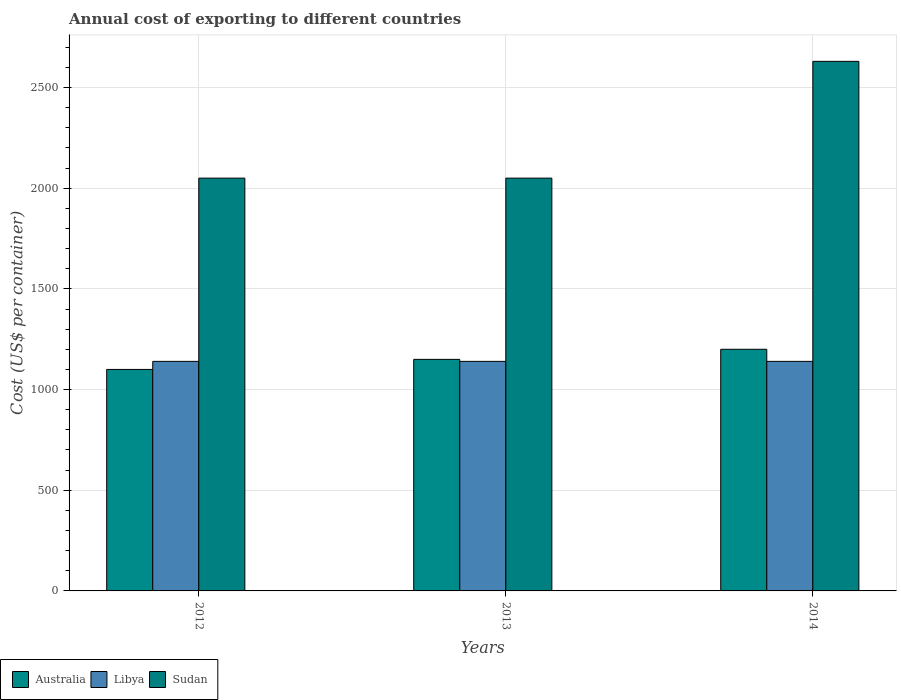How many different coloured bars are there?
Offer a terse response. 3. How many groups of bars are there?
Your response must be concise. 3. How many bars are there on the 1st tick from the left?
Offer a terse response. 3. What is the label of the 3rd group of bars from the left?
Offer a terse response. 2014. What is the total annual cost of exporting in Sudan in 2012?
Give a very brief answer. 2050. Across all years, what is the maximum total annual cost of exporting in Australia?
Provide a succinct answer. 1200. Across all years, what is the minimum total annual cost of exporting in Libya?
Your answer should be very brief. 1140. In which year was the total annual cost of exporting in Libya maximum?
Provide a short and direct response. 2012. What is the total total annual cost of exporting in Libya in the graph?
Offer a terse response. 3420. What is the difference between the total annual cost of exporting in Sudan in 2012 and that in 2014?
Provide a short and direct response. -580. What is the difference between the total annual cost of exporting in Australia in 2014 and the total annual cost of exporting in Sudan in 2012?
Make the answer very short. -850. What is the average total annual cost of exporting in Australia per year?
Keep it short and to the point. 1150. In the year 2013, what is the difference between the total annual cost of exporting in Sudan and total annual cost of exporting in Libya?
Offer a terse response. 910. What is the ratio of the total annual cost of exporting in Sudan in 2013 to that in 2014?
Ensure brevity in your answer.  0.78. Is the difference between the total annual cost of exporting in Sudan in 2012 and 2014 greater than the difference between the total annual cost of exporting in Libya in 2012 and 2014?
Your answer should be compact. No. What is the difference between the highest and the lowest total annual cost of exporting in Australia?
Ensure brevity in your answer.  100. Is the sum of the total annual cost of exporting in Australia in 2012 and 2013 greater than the maximum total annual cost of exporting in Libya across all years?
Your answer should be very brief. Yes. What does the 3rd bar from the left in 2012 represents?
Your answer should be very brief. Sudan. What does the 2nd bar from the right in 2013 represents?
Your answer should be compact. Libya. Is it the case that in every year, the sum of the total annual cost of exporting in Australia and total annual cost of exporting in Sudan is greater than the total annual cost of exporting in Libya?
Offer a very short reply. Yes. How many bars are there?
Make the answer very short. 9. What is the difference between two consecutive major ticks on the Y-axis?
Provide a short and direct response. 500. Are the values on the major ticks of Y-axis written in scientific E-notation?
Offer a terse response. No. Does the graph contain any zero values?
Your response must be concise. No. Does the graph contain grids?
Ensure brevity in your answer.  Yes. How are the legend labels stacked?
Ensure brevity in your answer.  Horizontal. What is the title of the graph?
Offer a very short reply. Annual cost of exporting to different countries. What is the label or title of the X-axis?
Your answer should be very brief. Years. What is the label or title of the Y-axis?
Offer a terse response. Cost (US$ per container). What is the Cost (US$ per container) in Australia in 2012?
Keep it short and to the point. 1100. What is the Cost (US$ per container) of Libya in 2012?
Give a very brief answer. 1140. What is the Cost (US$ per container) in Sudan in 2012?
Offer a terse response. 2050. What is the Cost (US$ per container) in Australia in 2013?
Make the answer very short. 1150. What is the Cost (US$ per container) of Libya in 2013?
Keep it short and to the point. 1140. What is the Cost (US$ per container) of Sudan in 2013?
Give a very brief answer. 2050. What is the Cost (US$ per container) of Australia in 2014?
Offer a terse response. 1200. What is the Cost (US$ per container) in Libya in 2014?
Offer a very short reply. 1140. What is the Cost (US$ per container) of Sudan in 2014?
Offer a terse response. 2630. Across all years, what is the maximum Cost (US$ per container) in Australia?
Offer a very short reply. 1200. Across all years, what is the maximum Cost (US$ per container) of Libya?
Give a very brief answer. 1140. Across all years, what is the maximum Cost (US$ per container) in Sudan?
Offer a terse response. 2630. Across all years, what is the minimum Cost (US$ per container) of Australia?
Provide a succinct answer. 1100. Across all years, what is the minimum Cost (US$ per container) of Libya?
Provide a succinct answer. 1140. Across all years, what is the minimum Cost (US$ per container) in Sudan?
Your answer should be compact. 2050. What is the total Cost (US$ per container) in Australia in the graph?
Make the answer very short. 3450. What is the total Cost (US$ per container) of Libya in the graph?
Make the answer very short. 3420. What is the total Cost (US$ per container) in Sudan in the graph?
Your answer should be very brief. 6730. What is the difference between the Cost (US$ per container) of Australia in 2012 and that in 2014?
Your answer should be compact. -100. What is the difference between the Cost (US$ per container) in Sudan in 2012 and that in 2014?
Provide a succinct answer. -580. What is the difference between the Cost (US$ per container) of Sudan in 2013 and that in 2014?
Offer a terse response. -580. What is the difference between the Cost (US$ per container) in Australia in 2012 and the Cost (US$ per container) in Sudan in 2013?
Ensure brevity in your answer.  -950. What is the difference between the Cost (US$ per container) in Libya in 2012 and the Cost (US$ per container) in Sudan in 2013?
Give a very brief answer. -910. What is the difference between the Cost (US$ per container) of Australia in 2012 and the Cost (US$ per container) of Libya in 2014?
Your answer should be compact. -40. What is the difference between the Cost (US$ per container) in Australia in 2012 and the Cost (US$ per container) in Sudan in 2014?
Provide a succinct answer. -1530. What is the difference between the Cost (US$ per container) in Libya in 2012 and the Cost (US$ per container) in Sudan in 2014?
Give a very brief answer. -1490. What is the difference between the Cost (US$ per container) in Australia in 2013 and the Cost (US$ per container) in Sudan in 2014?
Give a very brief answer. -1480. What is the difference between the Cost (US$ per container) of Libya in 2013 and the Cost (US$ per container) of Sudan in 2014?
Provide a short and direct response. -1490. What is the average Cost (US$ per container) of Australia per year?
Give a very brief answer. 1150. What is the average Cost (US$ per container) of Libya per year?
Provide a succinct answer. 1140. What is the average Cost (US$ per container) in Sudan per year?
Your response must be concise. 2243.33. In the year 2012, what is the difference between the Cost (US$ per container) of Australia and Cost (US$ per container) of Libya?
Provide a succinct answer. -40. In the year 2012, what is the difference between the Cost (US$ per container) in Australia and Cost (US$ per container) in Sudan?
Provide a succinct answer. -950. In the year 2012, what is the difference between the Cost (US$ per container) of Libya and Cost (US$ per container) of Sudan?
Offer a terse response. -910. In the year 2013, what is the difference between the Cost (US$ per container) in Australia and Cost (US$ per container) in Sudan?
Keep it short and to the point. -900. In the year 2013, what is the difference between the Cost (US$ per container) in Libya and Cost (US$ per container) in Sudan?
Offer a terse response. -910. In the year 2014, what is the difference between the Cost (US$ per container) of Australia and Cost (US$ per container) of Libya?
Your response must be concise. 60. In the year 2014, what is the difference between the Cost (US$ per container) of Australia and Cost (US$ per container) of Sudan?
Offer a very short reply. -1430. In the year 2014, what is the difference between the Cost (US$ per container) of Libya and Cost (US$ per container) of Sudan?
Offer a terse response. -1490. What is the ratio of the Cost (US$ per container) in Australia in 2012 to that in 2013?
Offer a terse response. 0.96. What is the ratio of the Cost (US$ per container) in Sudan in 2012 to that in 2013?
Keep it short and to the point. 1. What is the ratio of the Cost (US$ per container) in Sudan in 2012 to that in 2014?
Offer a very short reply. 0.78. What is the ratio of the Cost (US$ per container) of Australia in 2013 to that in 2014?
Offer a terse response. 0.96. What is the ratio of the Cost (US$ per container) in Sudan in 2013 to that in 2014?
Provide a short and direct response. 0.78. What is the difference between the highest and the second highest Cost (US$ per container) in Libya?
Provide a succinct answer. 0. What is the difference between the highest and the second highest Cost (US$ per container) in Sudan?
Provide a short and direct response. 580. What is the difference between the highest and the lowest Cost (US$ per container) in Australia?
Your answer should be compact. 100. What is the difference between the highest and the lowest Cost (US$ per container) in Sudan?
Offer a terse response. 580. 